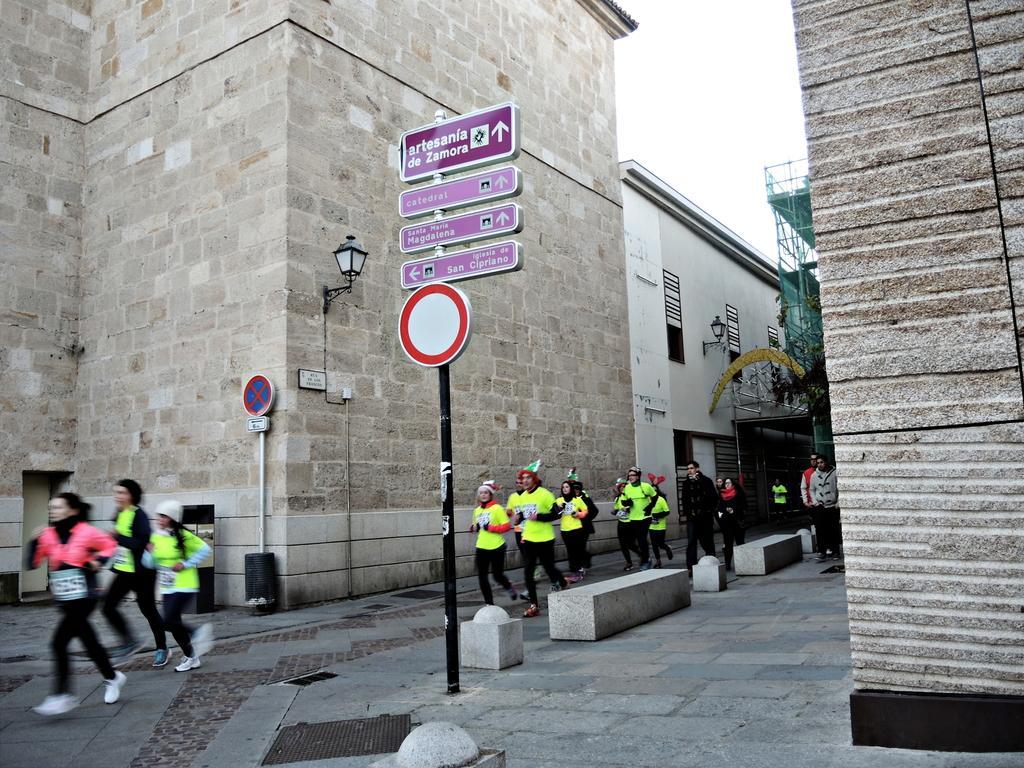What is the main object in the center of the image? There is a sign board in the center of the image. What are the people in the image doing? The people in the image are running on the road. What can be seen in the background of the image? There are buildings in the background of the image. What type of animal is running alongside the people in the image? There are no animals present in the image; only people are running on the road. Who is the partner of the person running in the image? The image does not provide information about partners or relationships between the people running. 